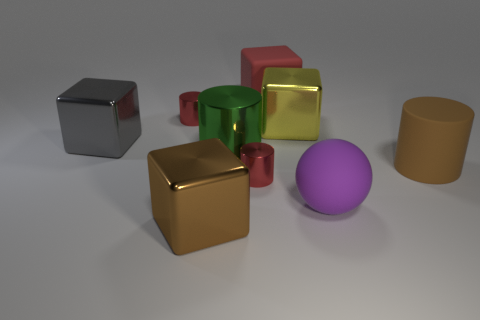Add 1 tiny red metal things. How many objects exist? 10 Subtract all spheres. How many objects are left? 8 Subtract 1 purple spheres. How many objects are left? 8 Subtract all green shiny things. Subtract all tiny objects. How many objects are left? 6 Add 6 big cylinders. How many big cylinders are left? 8 Add 5 tiny red cylinders. How many tiny red cylinders exist? 7 